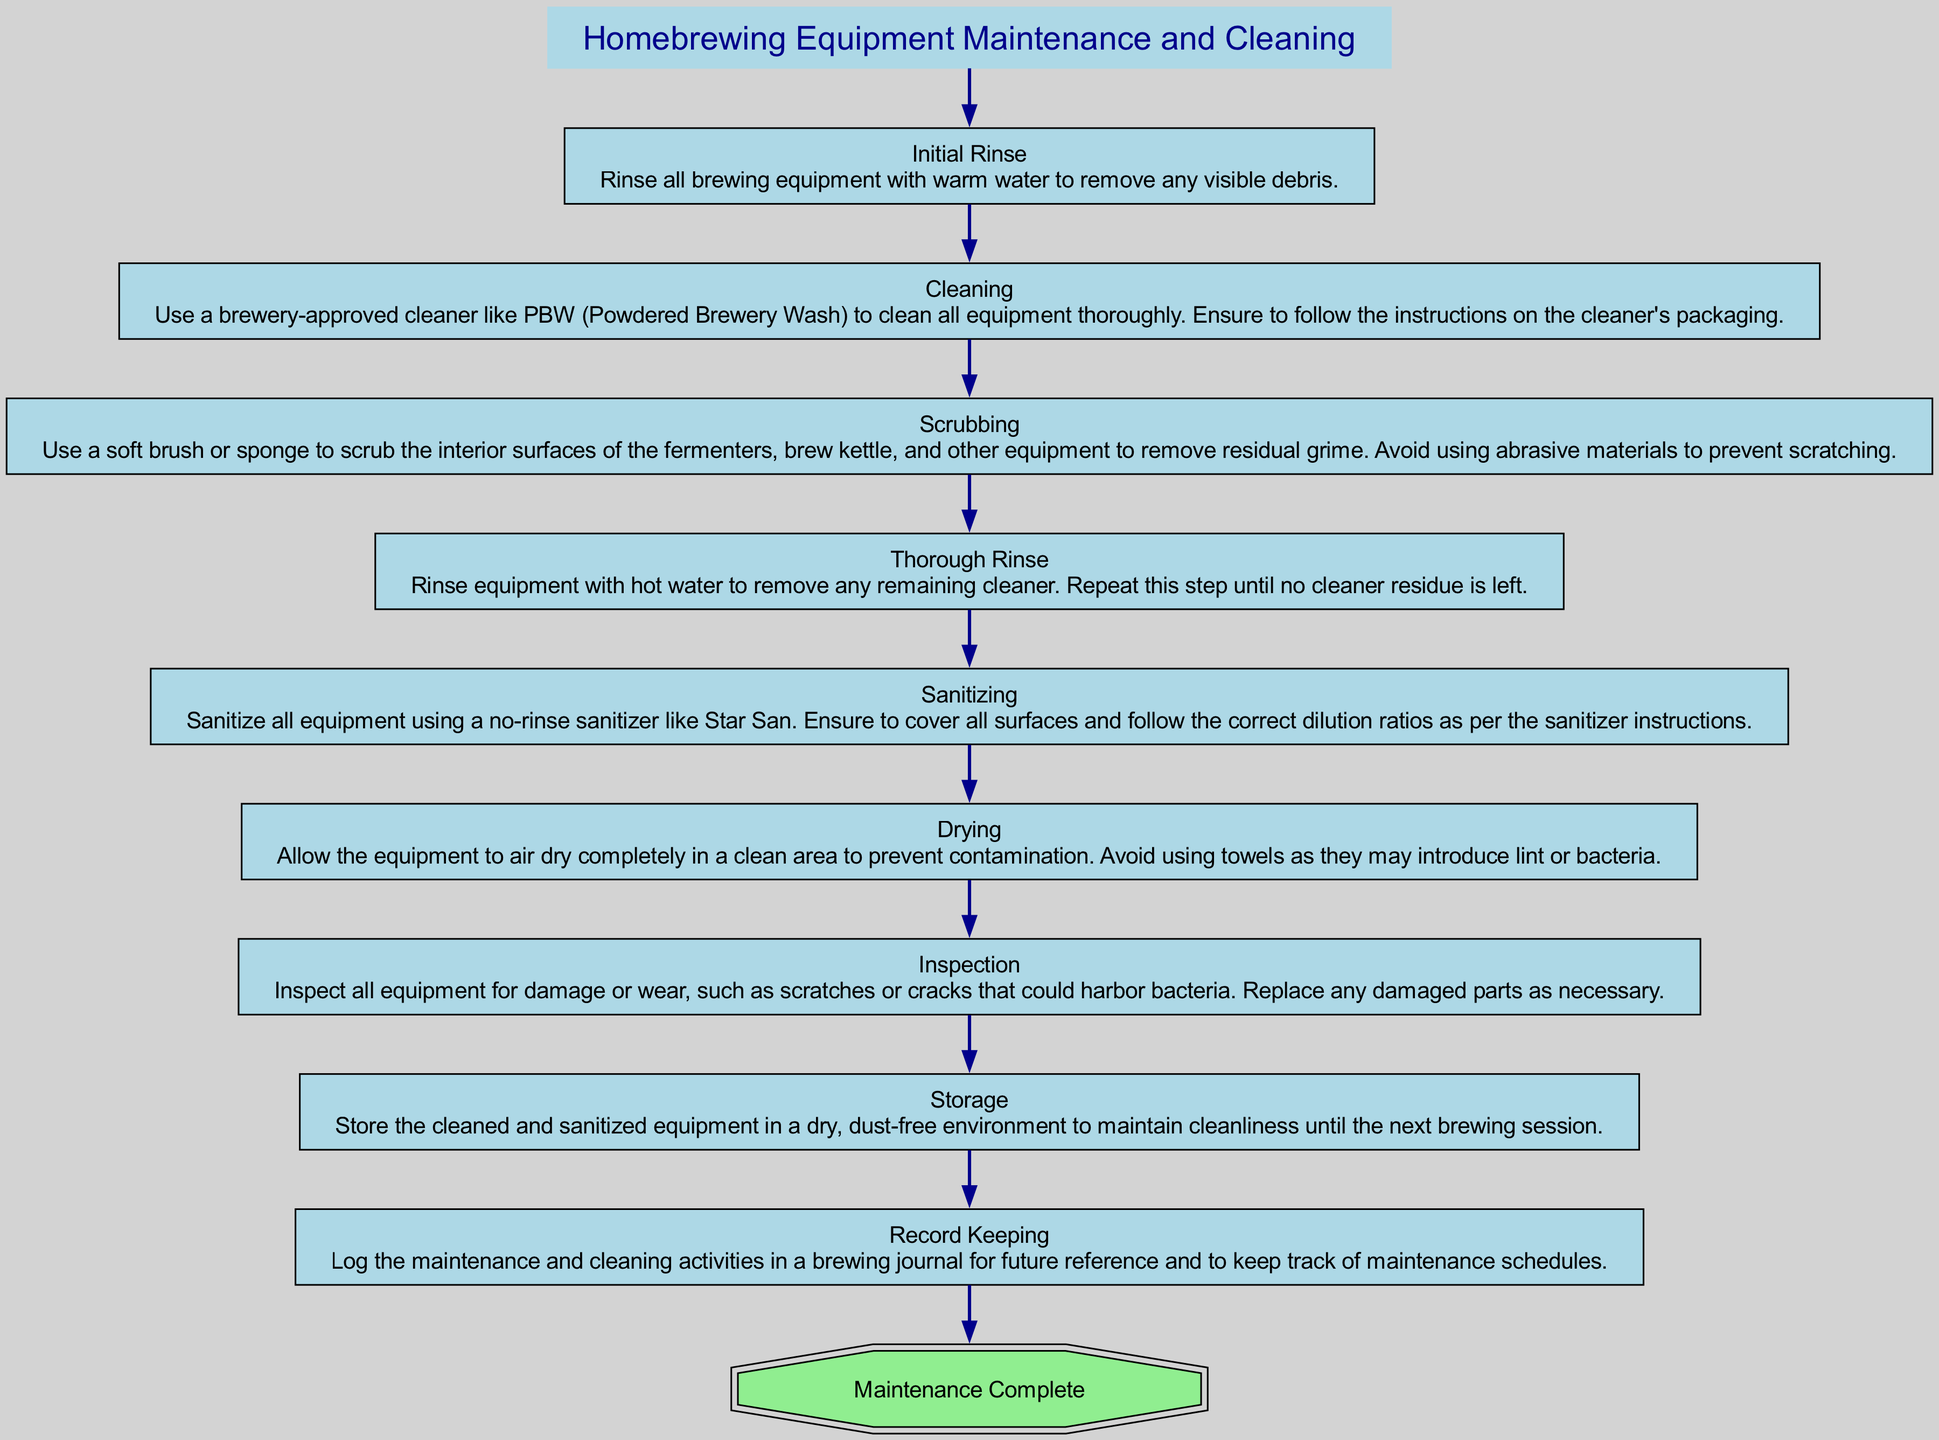What is the first step in the maintenance process? The first step indicated in the flowchart is "Initial Rinse," which is the action that begins the maintenance process to remove visible debris.
Answer: Initial Rinse How many steps are there in total? By counting all the nodes in the diagram, there are a total of nine steps listed in the maintenance process.
Answer: 9 What follows after "Sanitizing"? The next step that follows "Sanitizing" in the flowchart is "Drying," indicating the equipment needs to be air-dried after sanitization.
Answer: Drying What type of sanitizer is recommended for sanitizing equipment? The recommended sanitizer mentioned in the flowchart is a "no-rinse sanitizer" specifically named Star San.
Answer: Star San What is the final step of the process? The last node in the diagram indicates that "Record Keeping" is the final step in maintaining and cleaning homebrewing equipment before storage and tracking activities.
Answer: Record Keeping Which step involves checking for damage or wear? The step designated for checking equipment for damage or wear is called "Inspection," which suggests an evaluation of the equipment's condition.
Answer: Inspection How should equipment be stored? The storage condition specified in the flowchart requires that the cleaned and sanitized equipment is to be kept in a "dry, dust-free environment" until the next use.
Answer: Dry, dust-free environment What equipment cleaning method is suggested? The flowchart specifies using a "brewery-approved cleaner" like PBW, which should be followed according to the packaging instructions for effective cleaning.
Answer: PBW 